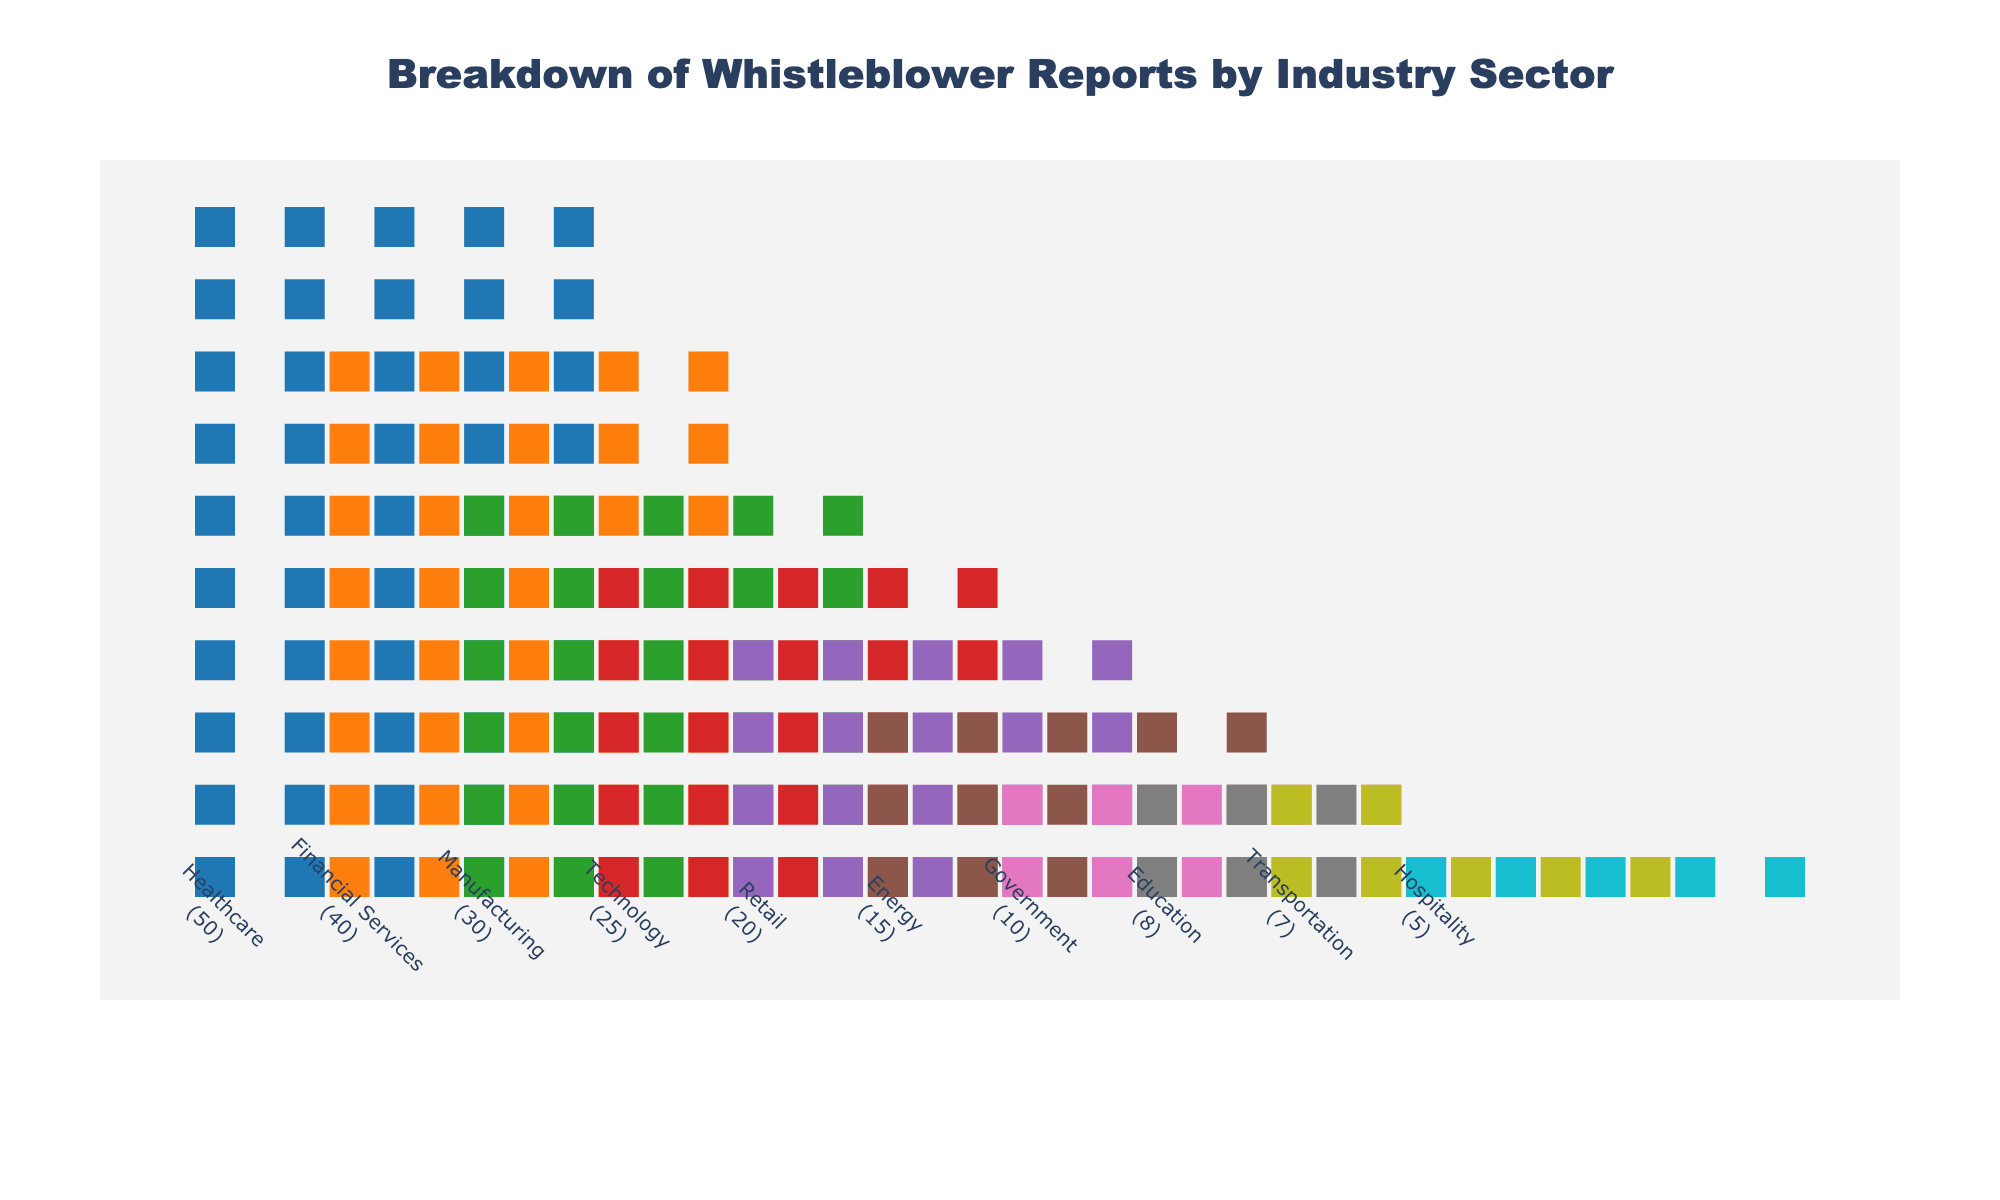What is the title of the plot? The title is usually depicted at the top of the figure and summarizes the information presented.
Answer: Breakdown of Whistleblower Reports by Industry Sector Which industry has the most whistleblower reports? To find the industry with the most reports, look for the industry with the highest number of icons stacked vertically.
Answer: Healthcare How many whistleblower reports are from the Technology sector? Count the number of icons in the Technology sector, or refer to the number provided next to the sector name.
Answer: 25 Which two sectors have the least whistleblower reports? Identify the two sectors with the smallest number of icons or the lowest numbers provided.
Answer: Hospitality and Transportation What is the sum of reports from Healthcare and Financial Services? Add the reports from these two sectors: 50 (Healthcare) + 40 (Financial Services).
Answer: 90 Which sector has exactly half the number of reports as the Healthcare sector? Since Healthcare has 50 reports, find the sector with 50 / 2 = 25 reports.
Answer: Technology Is the number of whistleblower reports in the Manufacturing sector greater than in the Retail sector? Compare the numbers of reports for Manufacturing (30) and Retail (20).
Answer: Yes What is the total number of whistleblower reports across all sectors? Sum all the provided numbers: 50 + 40 + 30 + 25 + 20 + 15 + 10 + 8 + 7 + 5.
Answer: 210 How many sectors have more than 20 whistleblower reports? Count the sectors with numbers greater than 20: Healthcare, Financial Services, Manufacturing, and Technology.
Answer: Four What is the average number of reports per sector? Determine by dividing the total number of reports by the number of sectors: 210 / 10.
Answer: 21 